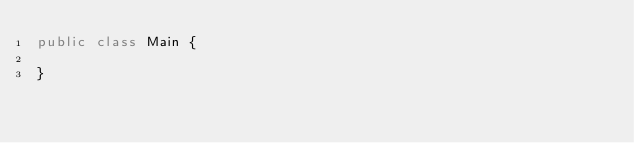Convert code to text. <code><loc_0><loc_0><loc_500><loc_500><_Java_>public class Main {

}
</code> 